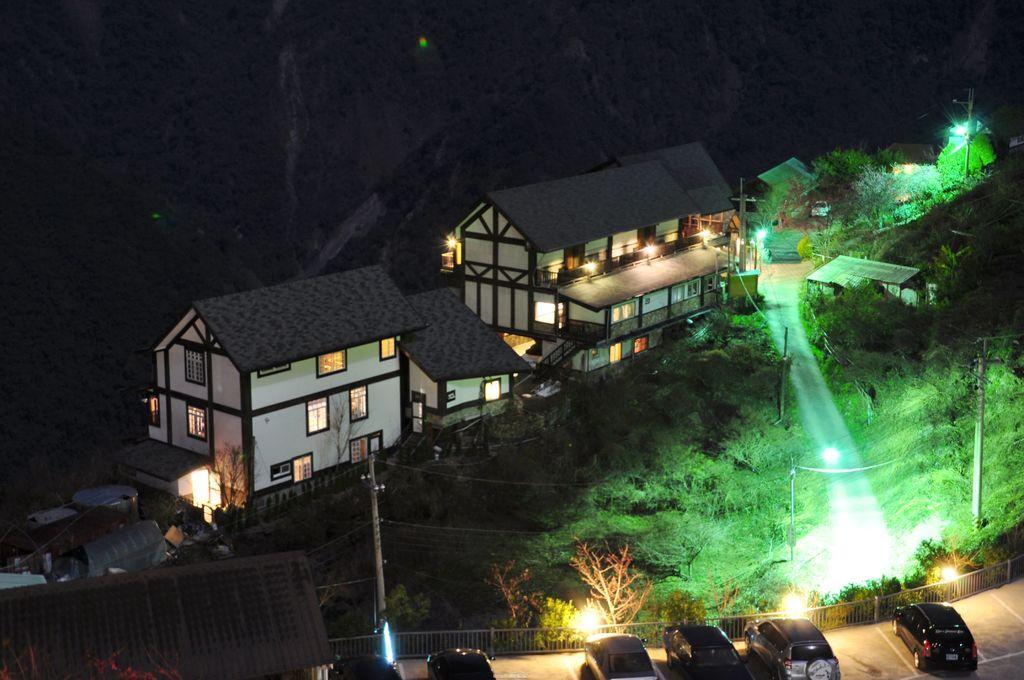Please provide a concise description of this image. At the bottom of the image there are few cars on the road. In front of them there is a fencing. And at the left corner of the image there is a roof. Behind the fencing there are electrical poles with wires and also there are many trees. And there are many houses with roofs, walls and windows. And on the houses there are lights. At the top of the image there is a black background. 